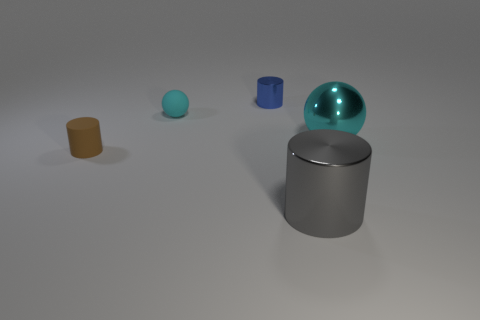Subtract all metal cylinders. How many cylinders are left? 1 Subtract all gray cylinders. How many cylinders are left? 2 Add 1 small yellow matte objects. How many objects exist? 6 Subtract 1 balls. How many balls are left? 1 Subtract all cylinders. How many objects are left? 2 Subtract all purple spheres. How many blue cylinders are left? 1 Subtract 0 gray balls. How many objects are left? 5 Subtract all purple spheres. Subtract all brown cubes. How many spheres are left? 2 Subtract all big red objects. Subtract all blue shiny objects. How many objects are left? 4 Add 3 tiny cyan things. How many tiny cyan things are left? 4 